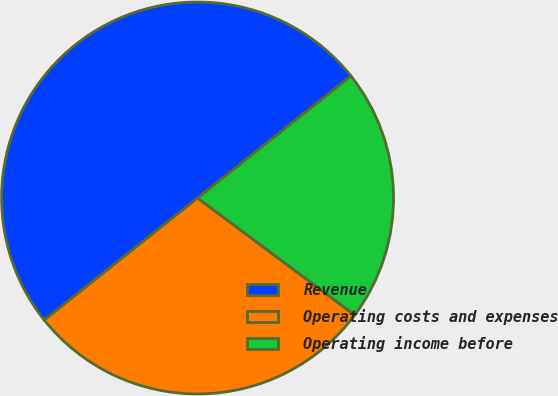Convert chart to OTSL. <chart><loc_0><loc_0><loc_500><loc_500><pie_chart><fcel>Revenue<fcel>Operating costs and expenses<fcel>Operating income before<nl><fcel>50.0%<fcel>29.11%<fcel>20.89%<nl></chart> 